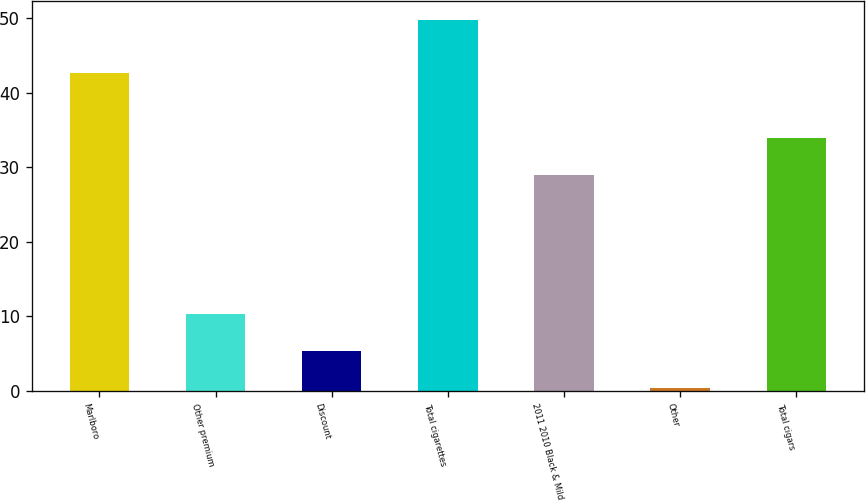Convert chart to OTSL. <chart><loc_0><loc_0><loc_500><loc_500><bar_chart><fcel>Marlboro<fcel>Other premium<fcel>Discount<fcel>Total cigarettes<fcel>2011 2010 Black & Mild<fcel>Other<fcel>Total cigars<nl><fcel>42.6<fcel>10.28<fcel>5.34<fcel>49.8<fcel>29<fcel>0.4<fcel>33.94<nl></chart> 